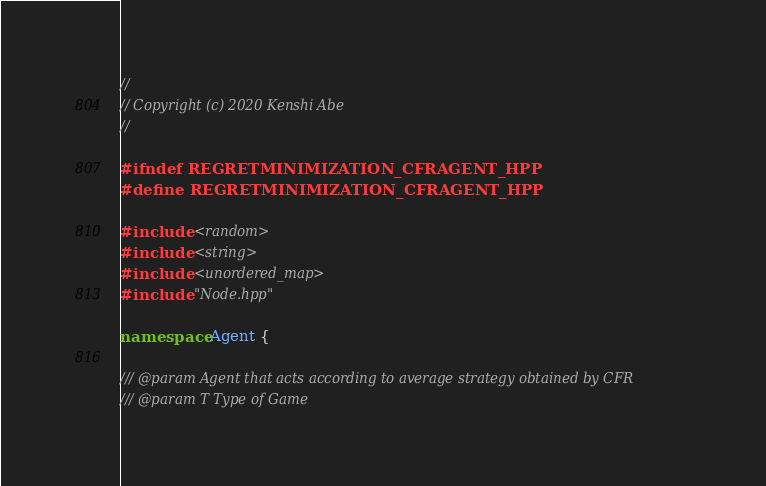<code> <loc_0><loc_0><loc_500><loc_500><_C++_>//
// Copyright (c) 2020 Kenshi Abe
//

#ifndef REGRETMINIMIZATION_CFRAGENT_HPP
#define REGRETMINIMIZATION_CFRAGENT_HPP

#include <random>
#include <string>
#include <unordered_map>
#include "Node.hpp"

namespace Agent {

/// @param Agent that acts according to average strategy obtained by CFR
/// @param T Type of Game</code> 